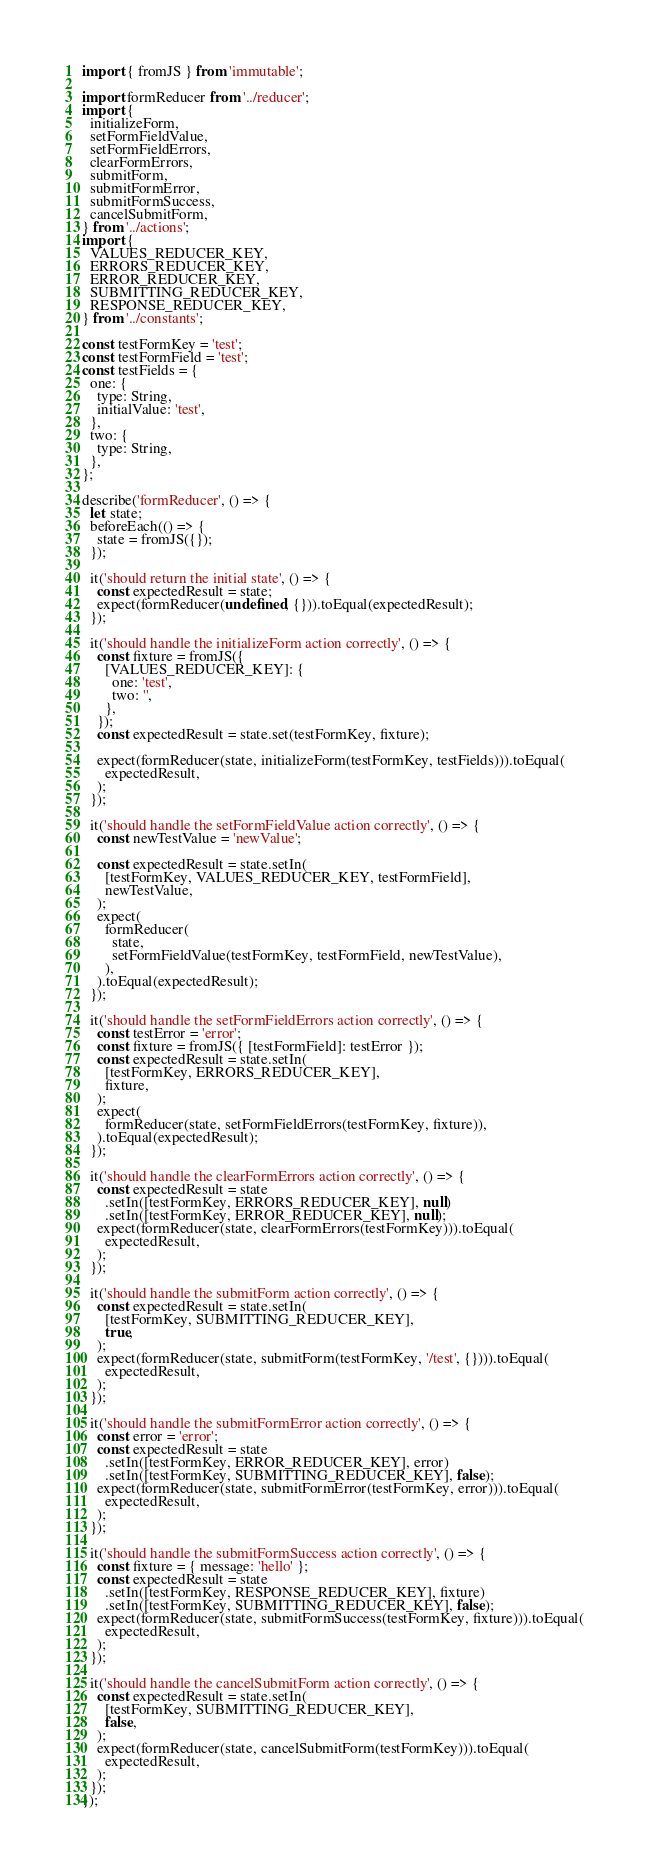<code> <loc_0><loc_0><loc_500><loc_500><_JavaScript_>import { fromJS } from 'immutable';

import formReducer from '../reducer';
import {
  initializeForm,
  setFormFieldValue,
  setFormFieldErrors,
  clearFormErrors,
  submitForm,
  submitFormError,
  submitFormSuccess,
  cancelSubmitForm,
} from '../actions';
import {
  VALUES_REDUCER_KEY,
  ERRORS_REDUCER_KEY,
  ERROR_REDUCER_KEY,
  SUBMITTING_REDUCER_KEY,
  RESPONSE_REDUCER_KEY,
} from '../constants';

const testFormKey = 'test';
const testFormField = 'test';
const testFields = {
  one: {
    type: String,
    initialValue: 'test',
  },
  two: {
    type: String,
  },
};

describe('formReducer', () => {
  let state;
  beforeEach(() => {
    state = fromJS({});
  });

  it('should return the initial state', () => {
    const expectedResult = state;
    expect(formReducer(undefined, {})).toEqual(expectedResult);
  });

  it('should handle the initializeForm action correctly', () => {
    const fixture = fromJS({
      [VALUES_REDUCER_KEY]: {
        one: 'test',
        two: '',
      },
    });
    const expectedResult = state.set(testFormKey, fixture);

    expect(formReducer(state, initializeForm(testFormKey, testFields))).toEqual(
      expectedResult,
    );
  });

  it('should handle the setFormFieldValue action correctly', () => {
    const newTestValue = 'newValue';

    const expectedResult = state.setIn(
      [testFormKey, VALUES_REDUCER_KEY, testFormField],
      newTestValue,
    );
    expect(
      formReducer(
        state,
        setFormFieldValue(testFormKey, testFormField, newTestValue),
      ),
    ).toEqual(expectedResult);
  });

  it('should handle the setFormFieldErrors action correctly', () => {
    const testError = 'error';
    const fixture = fromJS({ [testFormField]: testError });
    const expectedResult = state.setIn(
      [testFormKey, ERRORS_REDUCER_KEY],
      fixture,
    );
    expect(
      formReducer(state, setFormFieldErrors(testFormKey, fixture)),
    ).toEqual(expectedResult);
  });

  it('should handle the clearFormErrors action correctly', () => {
    const expectedResult = state
      .setIn([testFormKey, ERRORS_REDUCER_KEY], null)
      .setIn([testFormKey, ERROR_REDUCER_KEY], null);
    expect(formReducer(state, clearFormErrors(testFormKey))).toEqual(
      expectedResult,
    );
  });

  it('should handle the submitForm action correctly', () => {
    const expectedResult = state.setIn(
      [testFormKey, SUBMITTING_REDUCER_KEY],
      true,
    );
    expect(formReducer(state, submitForm(testFormKey, '/test', {}))).toEqual(
      expectedResult,
    );
  });

  it('should handle the submitFormError action correctly', () => {
    const error = 'error';
    const expectedResult = state
      .setIn([testFormKey, ERROR_REDUCER_KEY], error)
      .setIn([testFormKey, SUBMITTING_REDUCER_KEY], false);
    expect(formReducer(state, submitFormError(testFormKey, error))).toEqual(
      expectedResult,
    );
  });

  it('should handle the submitFormSuccess action correctly', () => {
    const fixture = { message: 'hello' };
    const expectedResult = state
      .setIn([testFormKey, RESPONSE_REDUCER_KEY], fixture)
      .setIn([testFormKey, SUBMITTING_REDUCER_KEY], false);
    expect(formReducer(state, submitFormSuccess(testFormKey, fixture))).toEqual(
      expectedResult,
    );
  });

  it('should handle the cancelSubmitForm action correctly', () => {
    const expectedResult = state.setIn(
      [testFormKey, SUBMITTING_REDUCER_KEY],
      false,
    );
    expect(formReducer(state, cancelSubmitForm(testFormKey))).toEqual(
      expectedResult,
    );
  });
});
</code> 